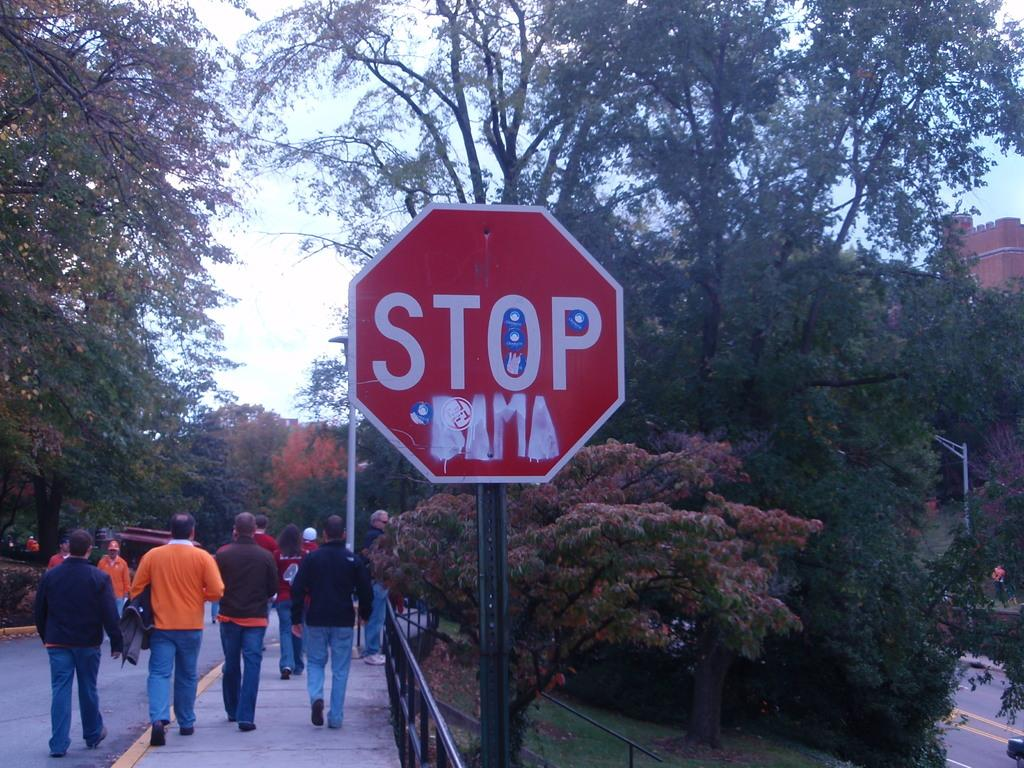<image>
Offer a succinct explanation of the picture presented. The red stop sign shown has been grafittied on. 